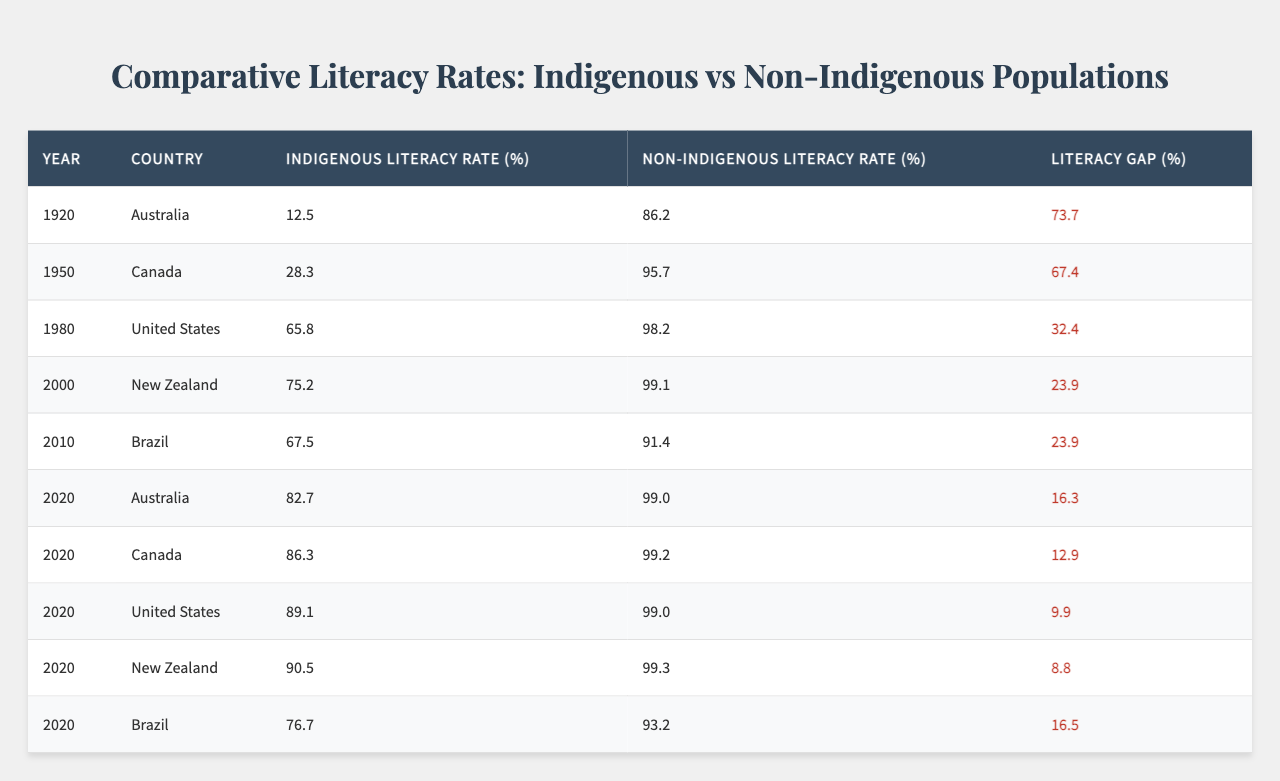What was the indigenous literacy rate in Australia in 1920? The table shows that the Indigenous Literacy Rate in Australia for the year 1920 was 12.5%.
Answer: 12.5% What is the literacy gap for Indigenous populations in Canada in 2020? The table states that the Literacy Gap for Indigenous populations in Canada in 2020 was 12.9%.
Answer: 12.9% Which country had the highest literacy rate for Indigenous populations in 2020? The table indicates that New Zealand had the highest Indigenous Literacy Rate in 2020 at 90.5%.
Answer: New Zealand What is the average Indigenous Literacy Rate across all countries for the year 2020? The Indigenous Literacy Rates in 2020 are: 82.7 (Australia), 86.3 (Canada), 89.1 (United States), 90.5 (New Zealand), and 76.7 (Brazil). The average is calculated by summing these rates (82.7 + 86.3 + 89.1 + 90.5 + 76.7 = 425.3) and dividing by 5, resulting in an average of 85.06%.
Answer: 85.06% Is the Indigenous Literacy Rate in the United States greater than that in Brazil for the year 2020? Looking at the table, the Indigenous Literacy Rate in the United States was 89.1%, while in Brazil it was 76.7%. Since 89.1% is greater than 76.7%, the statement is true.
Answer: Yes What trend can be observed in the literacy gap between Indigenous and Non-Indigenous populations in Australia from 1920 to 2020? The table shows that in 1920, the literacy gap was 73.7%, and by 2020, it had decreased significantly to 16.3%. This suggests a positive trend of increasing literacy rates among Indigenous populations in Australia over the century.
Answer: Decreasing trend What was the overall percent increase in Indigenous Literacy Rate in Brazil from 2000 to 2020? In Brazil, the Indigenous Literacy Rate was 67.5% in 2000 and rose to 76.7% in 2020. To find the percent increase, we calculate: (76.7 - 67.5) / 67.5 * 100 = 1.79%.
Answer: 1.79% In which year did the gap between Indigenous and Non-Indigenous literacy rates in Canada reach the smallest value? Reviewing the table, in 2020, the Literacy Gap in Canada was 12.9%, which is the smallest compared to previous years.
Answer: 2020 Did the Indigenous Literacy Rate exceed 70% in any country by the year 2000? The table shows that by 2000, the Indigenous Literacy Rate in New Zealand was 75.2%, which is above 70%. Therefore, the answer is yes.
Answer: Yes 